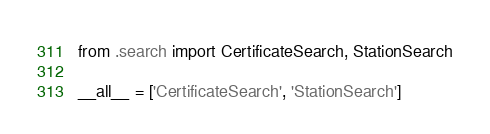Convert code to text. <code><loc_0><loc_0><loc_500><loc_500><_Python_>from .search import CertificateSearch, StationSearch

__all__ = ['CertificateSearch', 'StationSearch']</code> 